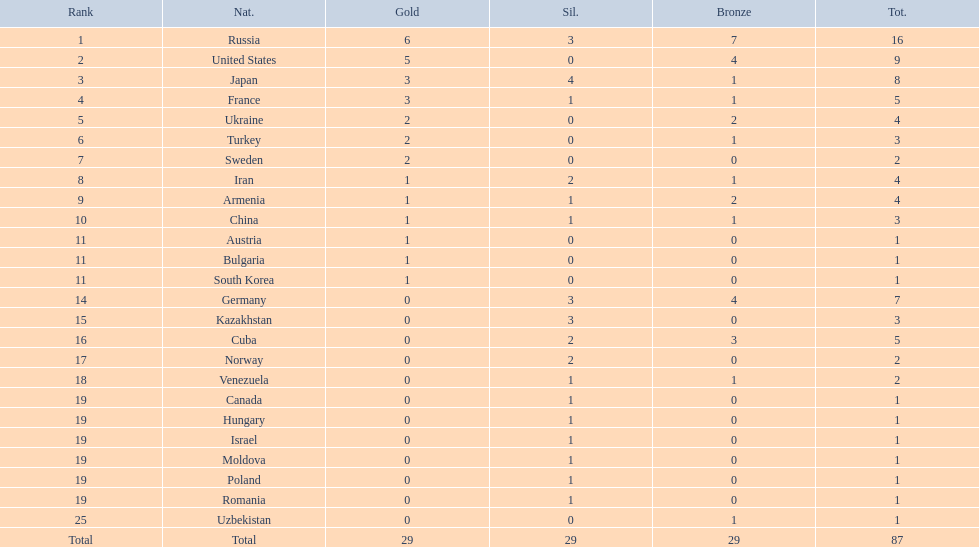Which nations participated in the championships? Russia, United States, Japan, France, Ukraine, Turkey, Sweden, Iran, Armenia, China, Austria, Bulgaria, South Korea, Germany, Kazakhstan, Cuba, Norway, Venezuela, Canada, Hungary, Israel, Moldova, Poland, Romania, Uzbekistan. How many bronze medals did they receive? 7, 4, 1, 1, 2, 1, 0, 1, 2, 1, 0, 0, 0, 4, 0, 3, 0, 1, 0, 0, 0, 0, 0, 0, 1, 29. How many in total? 16, 9, 8, 5, 4, 3, 2, 4, 4, 3, 1, 1, 1, 7, 3, 5, 2, 2, 1, 1, 1, 1, 1, 1, 1. And which team won only one medal -- the bronze? Uzbekistan. 